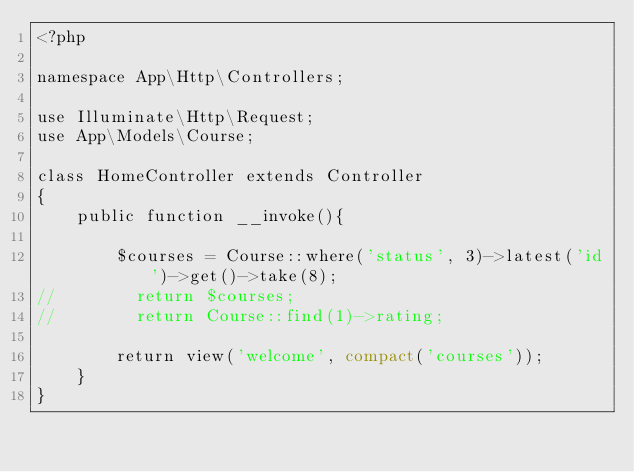<code> <loc_0><loc_0><loc_500><loc_500><_PHP_><?php

namespace App\Http\Controllers;

use Illuminate\Http\Request;
use App\Models\Course;

class HomeController extends Controller
{
    public function __invoke(){

        $courses = Course::where('status', 3)->latest('id')->get()->take(8);
//        return $courses;
//        return Course::find(1)->rating;

        return view('welcome', compact('courses'));
    }
}
</code> 